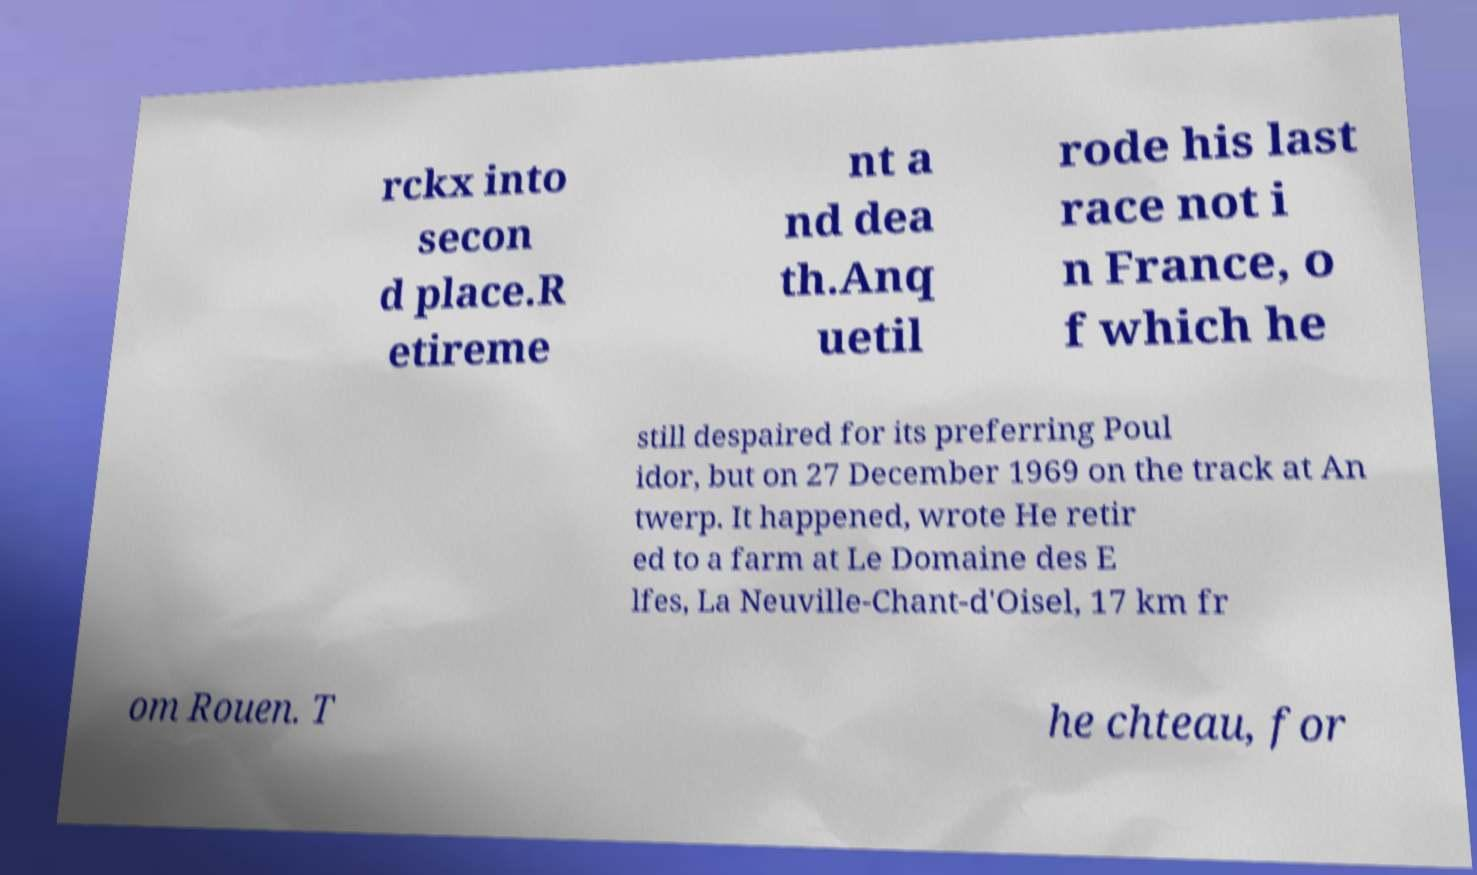Could you assist in decoding the text presented in this image and type it out clearly? rckx into secon d place.R etireme nt a nd dea th.Anq uetil rode his last race not i n France, o f which he still despaired for its preferring Poul idor, but on 27 December 1969 on the track at An twerp. It happened, wrote He retir ed to a farm at Le Domaine des E lfes, La Neuville-Chant-d'Oisel, 17 km fr om Rouen. T he chteau, for 